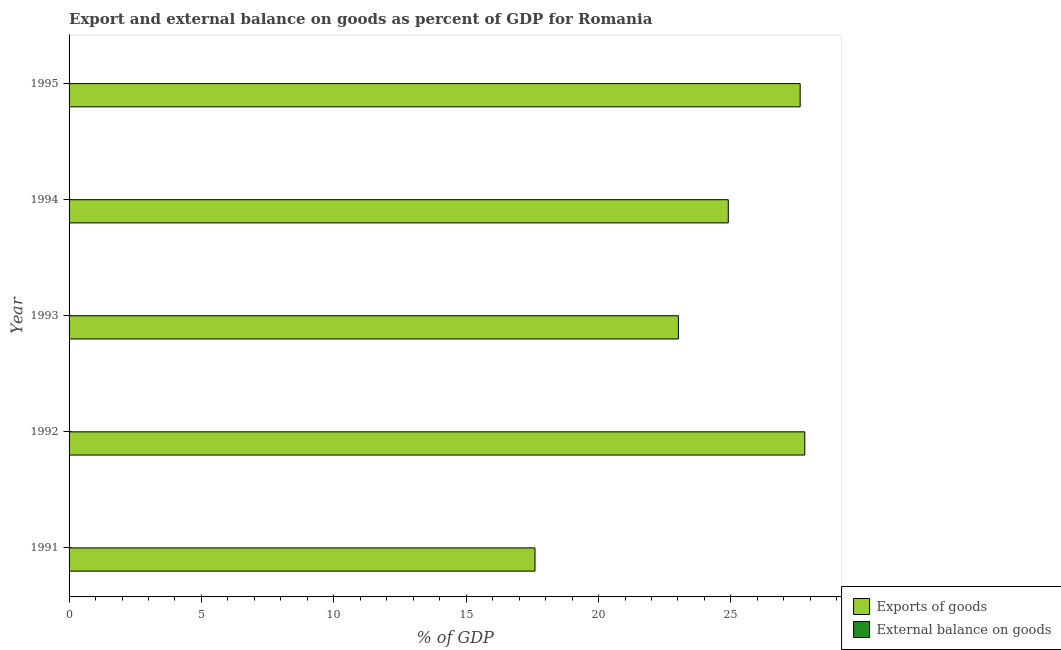How many different coloured bars are there?
Your answer should be very brief. 1. Are the number of bars per tick equal to the number of legend labels?
Keep it short and to the point. No. How many bars are there on the 1st tick from the top?
Provide a short and direct response. 1. How many bars are there on the 5th tick from the bottom?
Provide a succinct answer. 1. What is the label of the 1st group of bars from the top?
Make the answer very short. 1995. What is the export of goods as percentage of gdp in 1992?
Offer a terse response. 27.79. Across all years, what is the maximum export of goods as percentage of gdp?
Ensure brevity in your answer.  27.79. In which year was the export of goods as percentage of gdp maximum?
Give a very brief answer. 1992. What is the total export of goods as percentage of gdp in the graph?
Offer a very short reply. 120.93. What is the difference between the export of goods as percentage of gdp in 1991 and that in 1992?
Your response must be concise. -10.19. What is the difference between the external balance on goods as percentage of gdp in 1991 and the export of goods as percentage of gdp in 1992?
Provide a succinct answer. -27.79. What is the average external balance on goods as percentage of gdp per year?
Your answer should be very brief. 0. In how many years, is the export of goods as percentage of gdp greater than 23 %?
Make the answer very short. 4. What is the ratio of the export of goods as percentage of gdp in 1992 to that in 1994?
Make the answer very short. 1.12. What is the difference between the highest and the second highest export of goods as percentage of gdp?
Give a very brief answer. 0.17. What is the difference between the highest and the lowest export of goods as percentage of gdp?
Ensure brevity in your answer.  10.19. Is the sum of the export of goods as percentage of gdp in 1993 and 1995 greater than the maximum external balance on goods as percentage of gdp across all years?
Keep it short and to the point. Yes. Are all the bars in the graph horizontal?
Your answer should be very brief. Yes. What is the difference between two consecutive major ticks on the X-axis?
Offer a very short reply. 5. Are the values on the major ticks of X-axis written in scientific E-notation?
Offer a very short reply. No. Does the graph contain any zero values?
Make the answer very short. Yes. Does the graph contain grids?
Provide a short and direct response. No. Where does the legend appear in the graph?
Provide a succinct answer. Bottom right. What is the title of the graph?
Provide a succinct answer. Export and external balance on goods as percent of GDP for Romania. What is the label or title of the X-axis?
Your answer should be very brief. % of GDP. What is the label or title of the Y-axis?
Provide a short and direct response. Year. What is the % of GDP of Exports of goods in 1991?
Your answer should be compact. 17.6. What is the % of GDP in External balance on goods in 1991?
Ensure brevity in your answer.  0. What is the % of GDP in Exports of goods in 1992?
Offer a terse response. 27.79. What is the % of GDP of External balance on goods in 1992?
Your answer should be compact. 0. What is the % of GDP of Exports of goods in 1993?
Provide a succinct answer. 23.02. What is the % of GDP of External balance on goods in 1993?
Offer a very short reply. 0. What is the % of GDP of Exports of goods in 1994?
Ensure brevity in your answer.  24.9. What is the % of GDP in Exports of goods in 1995?
Your response must be concise. 27.62. What is the % of GDP in External balance on goods in 1995?
Provide a short and direct response. 0. Across all years, what is the maximum % of GDP of Exports of goods?
Your response must be concise. 27.79. Across all years, what is the minimum % of GDP of Exports of goods?
Ensure brevity in your answer.  17.6. What is the total % of GDP in Exports of goods in the graph?
Provide a short and direct response. 120.93. What is the difference between the % of GDP of Exports of goods in 1991 and that in 1992?
Your answer should be compact. -10.19. What is the difference between the % of GDP of Exports of goods in 1991 and that in 1993?
Provide a succinct answer. -5.42. What is the difference between the % of GDP of Exports of goods in 1991 and that in 1994?
Your response must be concise. -7.3. What is the difference between the % of GDP in Exports of goods in 1991 and that in 1995?
Offer a terse response. -10.02. What is the difference between the % of GDP in Exports of goods in 1992 and that in 1993?
Offer a very short reply. 4.78. What is the difference between the % of GDP in Exports of goods in 1992 and that in 1994?
Provide a succinct answer. 2.89. What is the difference between the % of GDP of Exports of goods in 1992 and that in 1995?
Your response must be concise. 0.17. What is the difference between the % of GDP of Exports of goods in 1993 and that in 1994?
Make the answer very short. -1.89. What is the difference between the % of GDP of Exports of goods in 1993 and that in 1995?
Your response must be concise. -4.6. What is the difference between the % of GDP in Exports of goods in 1994 and that in 1995?
Your answer should be compact. -2.72. What is the average % of GDP of Exports of goods per year?
Ensure brevity in your answer.  24.19. What is the average % of GDP of External balance on goods per year?
Your answer should be very brief. 0. What is the ratio of the % of GDP of Exports of goods in 1991 to that in 1992?
Your answer should be compact. 0.63. What is the ratio of the % of GDP of Exports of goods in 1991 to that in 1993?
Your answer should be very brief. 0.76. What is the ratio of the % of GDP of Exports of goods in 1991 to that in 1994?
Offer a very short reply. 0.71. What is the ratio of the % of GDP of Exports of goods in 1991 to that in 1995?
Your answer should be very brief. 0.64. What is the ratio of the % of GDP of Exports of goods in 1992 to that in 1993?
Give a very brief answer. 1.21. What is the ratio of the % of GDP of Exports of goods in 1992 to that in 1994?
Ensure brevity in your answer.  1.12. What is the ratio of the % of GDP of Exports of goods in 1992 to that in 1995?
Ensure brevity in your answer.  1.01. What is the ratio of the % of GDP of Exports of goods in 1993 to that in 1994?
Your answer should be compact. 0.92. What is the ratio of the % of GDP of Exports of goods in 1993 to that in 1995?
Offer a terse response. 0.83. What is the ratio of the % of GDP of Exports of goods in 1994 to that in 1995?
Your response must be concise. 0.9. What is the difference between the highest and the second highest % of GDP in Exports of goods?
Make the answer very short. 0.17. What is the difference between the highest and the lowest % of GDP in Exports of goods?
Offer a terse response. 10.19. 